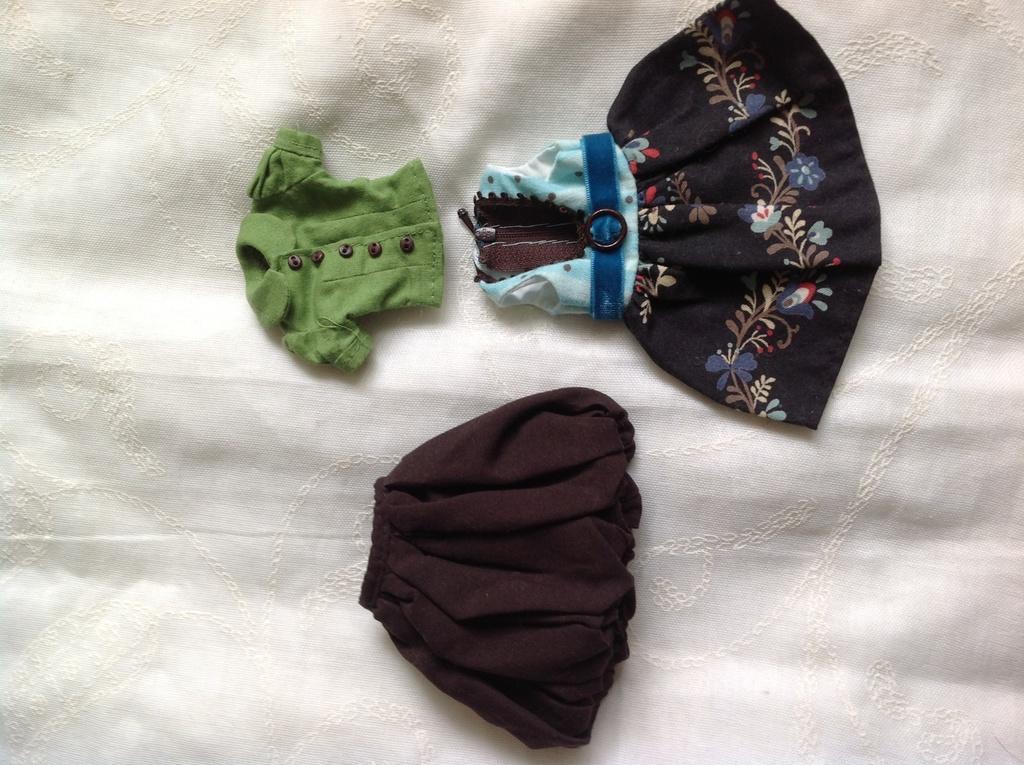Could you give a brief overview of what you see in this image? In this image a frock, a shirt and a shirt are placed on a white color cloth. 